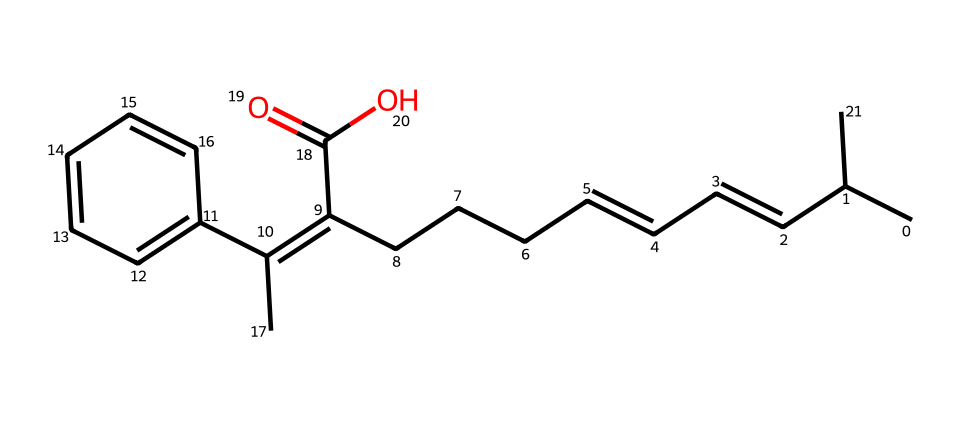What is the molecular formula of retinoic acid? To determine the molecular formula from the SMILES structure, we identify the number of each type of atom present. Analyzing the structure reveals the presence of 21 carbon atoms, 30 hydrogen atoms, and 2 oxygen atoms. This combination gives the molecular formula C21H30O2.
Answer: C21H30O2 How many rings are in this chemical structure? By examining the SMILES representation, we can see that there are no indicators of rings (which would be denoted by numbers that indicate bond connections in rings). Thus, we conclude that there are zero rings in this compound.
Answer: 0 What functional groups are present in retinoic acid? The presence of carboxylic acid (denoted by the -COOH group in the structure) and possibly alkenes (C=C) can be observed in the SMILES. These characterize retinoic acid's functional groups.
Answer: carboxylic acid, alkenes What is the role of retinoic acid in skincare? Retinoic acid serves as a potent form of vitamin A which promotes skin cell turnover and collagen production, enhancing skin texture and reducing signs of aging. This mechanism is beneficial for improving skin health.
Answer: promotes skin health How many double bonds are present in retinoic acid? By analyzing the structure, both the alkene double bonds and the carbon-carbon double bond connections are counted. In total, there are 5 double bonds present in the structure.
Answer: 5 Is retinoic acid a polar or nonpolar molecule? Considering the presence of the carboxylic acid group (-COOH), which is polar, alongside the larger hydrocarbon chains present, retinoic acid is primarily polar due to its functional groups.
Answer: polar 